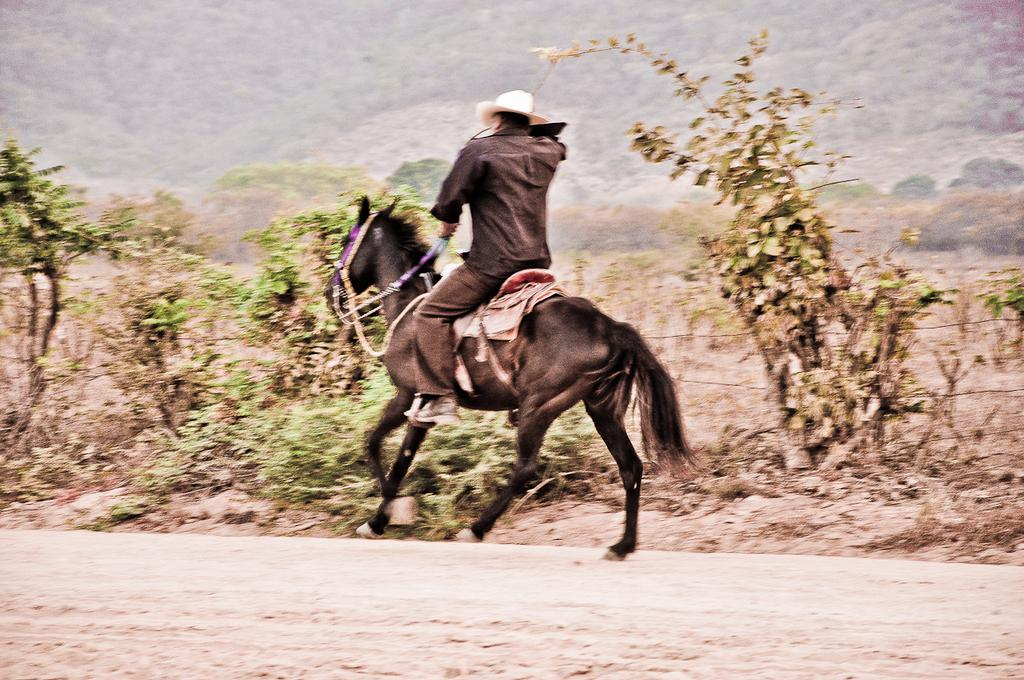What is the main subject in the center of the image? There is a man on a horse in the center of the image. What can be seen in the background of the image? There is greenery in the background of the image. What type of landscape feature is visible at the top of the image? It appears that there are mountains in the top side of the image. How is the knot tied on the horse's reins in the image? There is no knot visible on the horse's reins in the image. What type of power source is used to move the horse in the image? The horse is not being moved by any power source in the image; it is being ridden by a man. 